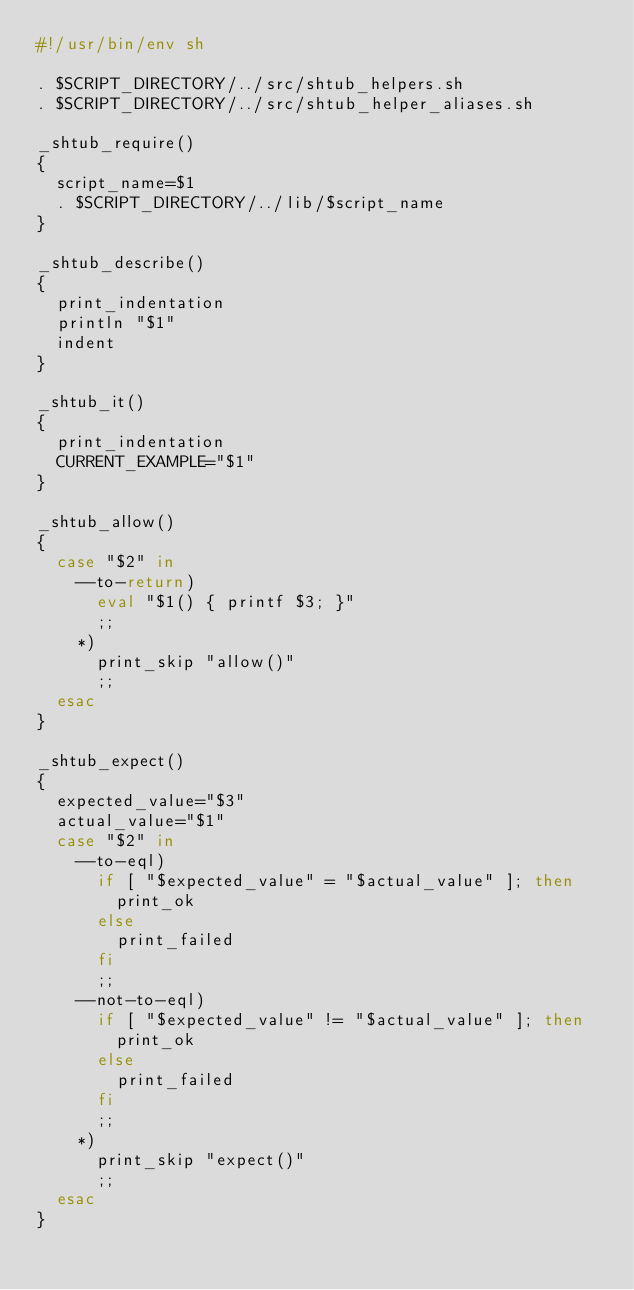<code> <loc_0><loc_0><loc_500><loc_500><_Bash_>#!/usr/bin/env sh

. $SCRIPT_DIRECTORY/../src/shtub_helpers.sh
. $SCRIPT_DIRECTORY/../src/shtub_helper_aliases.sh

_shtub_require()
{
  script_name=$1
  . $SCRIPT_DIRECTORY/../lib/$script_name
}

_shtub_describe()
{
  print_indentation
  println "$1"
  indent
}

_shtub_it()
{
  print_indentation
  CURRENT_EXAMPLE="$1"
}

_shtub_allow()
{
  case "$2" in
    --to-return)
      eval "$1() { printf $3; }"
      ;;
    *)
      print_skip "allow()"
      ;;
  esac
}

_shtub_expect()
{
  expected_value="$3"
  actual_value="$1"
  case "$2" in
    --to-eql)
      if [ "$expected_value" = "$actual_value" ]; then
        print_ok
      else
        print_failed
      fi
      ;;
    --not-to-eql)
      if [ "$expected_value" != "$actual_value" ]; then
        print_ok
      else
        print_failed
      fi
      ;;
    *)
      print_skip "expect()"
      ;;
  esac
}
</code> 